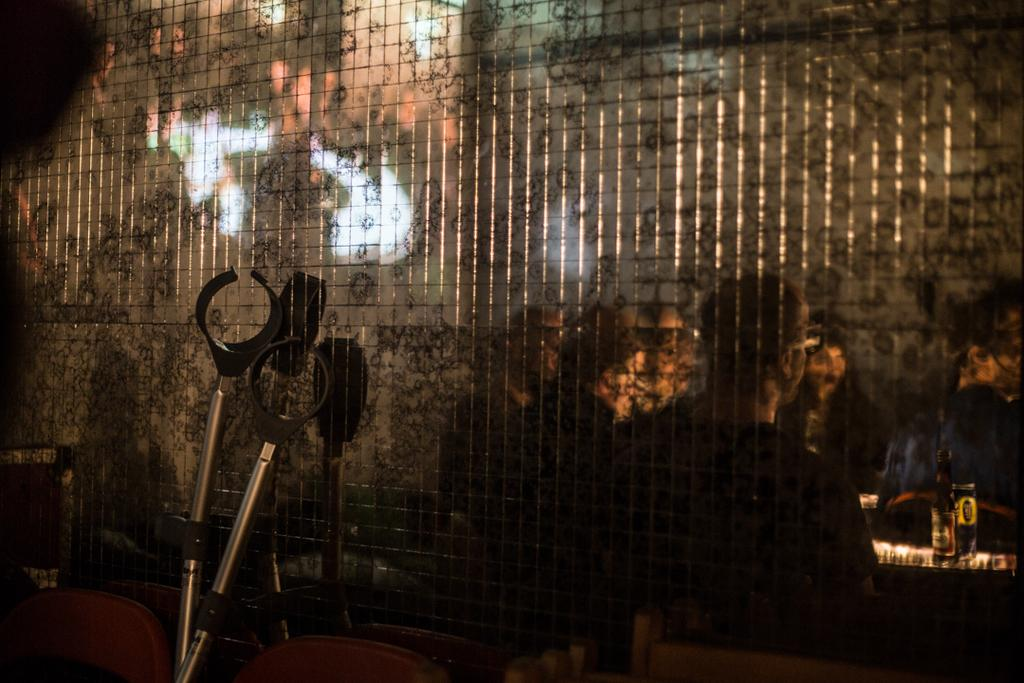Who or what can be seen in the image? There are people in the image. Where are the people located in the image? The people are on the right side of the image. What is the setting of the image? The people are inside a net window. What else can be seen in the image? There are rods on the left side of the image. How many spiders are crawling on the people in the image? There are no spiders present in the image. Can you describe the bite marks on the people in the image? There are no bite marks visible on the people in the image. 